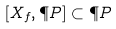Convert formula to latex. <formula><loc_0><loc_0><loc_500><loc_500>[ X _ { f } , \P P ] \subset \P P</formula> 